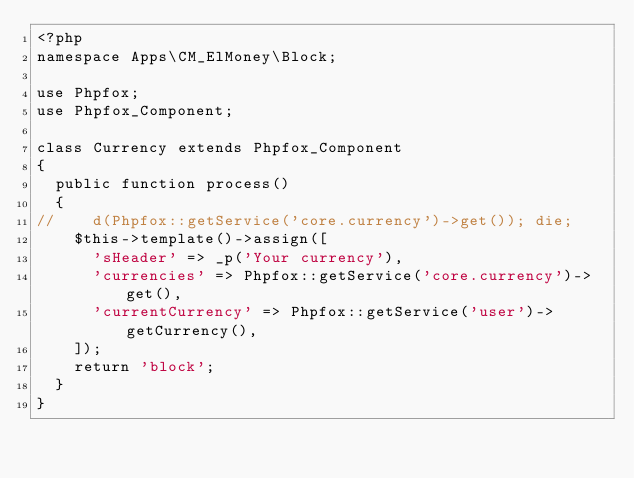<code> <loc_0><loc_0><loc_500><loc_500><_PHP_><?php
namespace Apps\CM_ElMoney\Block;

use Phpfox;
use Phpfox_Component;

class Currency extends Phpfox_Component
{
	public function process()
	{
//		d(Phpfox::getService('core.currency')->get()); die;
		$this->template()->assign([
			'sHeader' => _p('Your currency'),
			'currencies' => Phpfox::getService('core.currency')->get(),
			'currentCurrency' => Phpfox::getService('user')->getCurrency(),
		]);
		return 'block';
	}
}</code> 